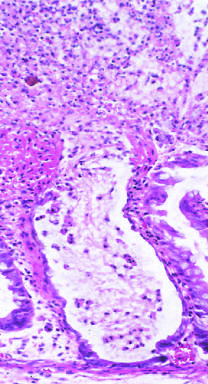s the typical pattern of neutrophils emanating from a crypt reminiscent of a volcanic eruption?
Answer the question using a single word or phrase. Yes 